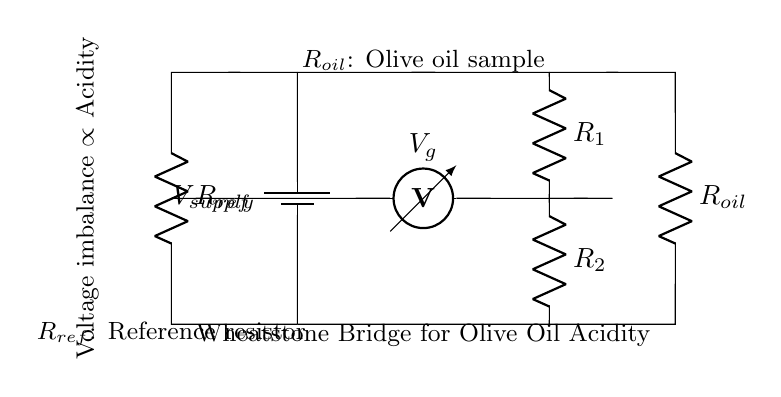What are the components of the Wheatstone bridge? The components include a voltage supply, a reference resistor, an olive oil sample resistor, and a voltmeter. Each of these plays a crucial role in measuring the voltage imbalance due to the differences in resistance.
Answer: voltage supply, reference resistor, olive oil sample resistor, voltmeter What does the voltmeter measure in this circuit? The voltmeter measures the voltage difference between the two points where it is connected (between R1 and R2). This difference indicates the imbalance in resistance between the reference resistor and the olive oil sample resistor, which correlates with the acidity level.
Answer: voltage difference What does the reference resistor represent? The reference resistor is a fixed standard against which the resistance of the olive oil sample is compared. It is crucial for establishing a baseline measurement in the circuit.
Answer: fixed standard How is voltage imbalance related to acidity? The voltage imbalance between the two branches of the Wheatstone bridge is directly proportional to the difference in resistance caused by the acidity level in the olive oil sample. Higher acidity typically leads to lower resistance, affecting the voltage measured by the voltmeter.
Answer: directly proportional What does an increase in olive oil acidity do to the voltmeter reading? An increase in olive oil acidity generally causes the resistance of the olive oil sample resistor to decrease, leading to a larger voltage imbalance. Therefore, the voltmeter reading will show a change that reflects this acidity increase.
Answer: larger voltage imbalance What are the resistors labeled in the circuit? The resistors are labeled as R1, R2, Rref (reference resistor), and R oil (olive oil sample). Each label indicates their role in the measurement process within the Wheatstone bridge configuration.
Answer: R1, R2, Rref, R oil 